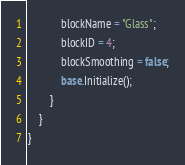<code> <loc_0><loc_0><loc_500><loc_500><_C#_>            blockName = "Glass";
            blockID = 4;
            blockSmoothing = false;
            base.Initialize();
        }
    }
}</code> 